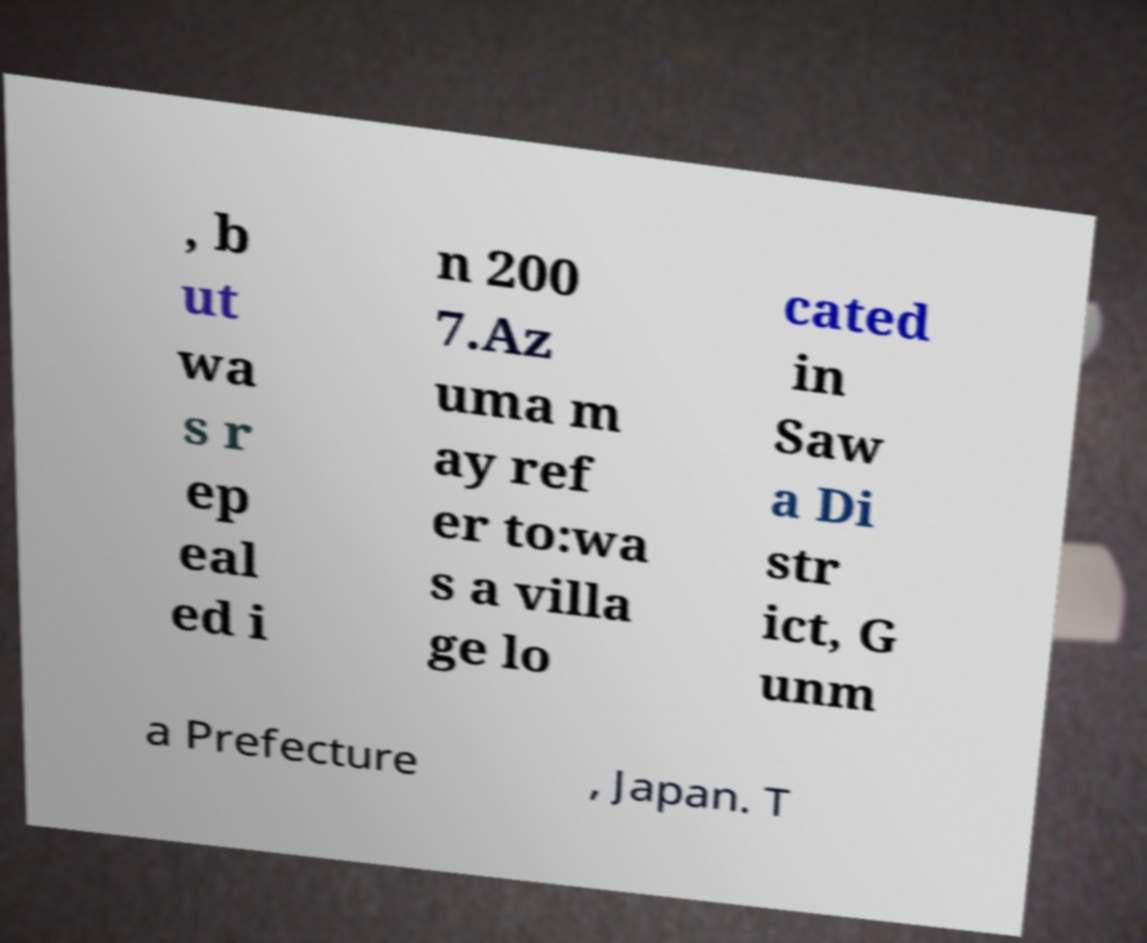What messages or text are displayed in this image? I need them in a readable, typed format. , b ut wa s r ep eal ed i n 200 7.Az uma m ay ref er to:wa s a villa ge lo cated in Saw a Di str ict, G unm a Prefecture , Japan. T 